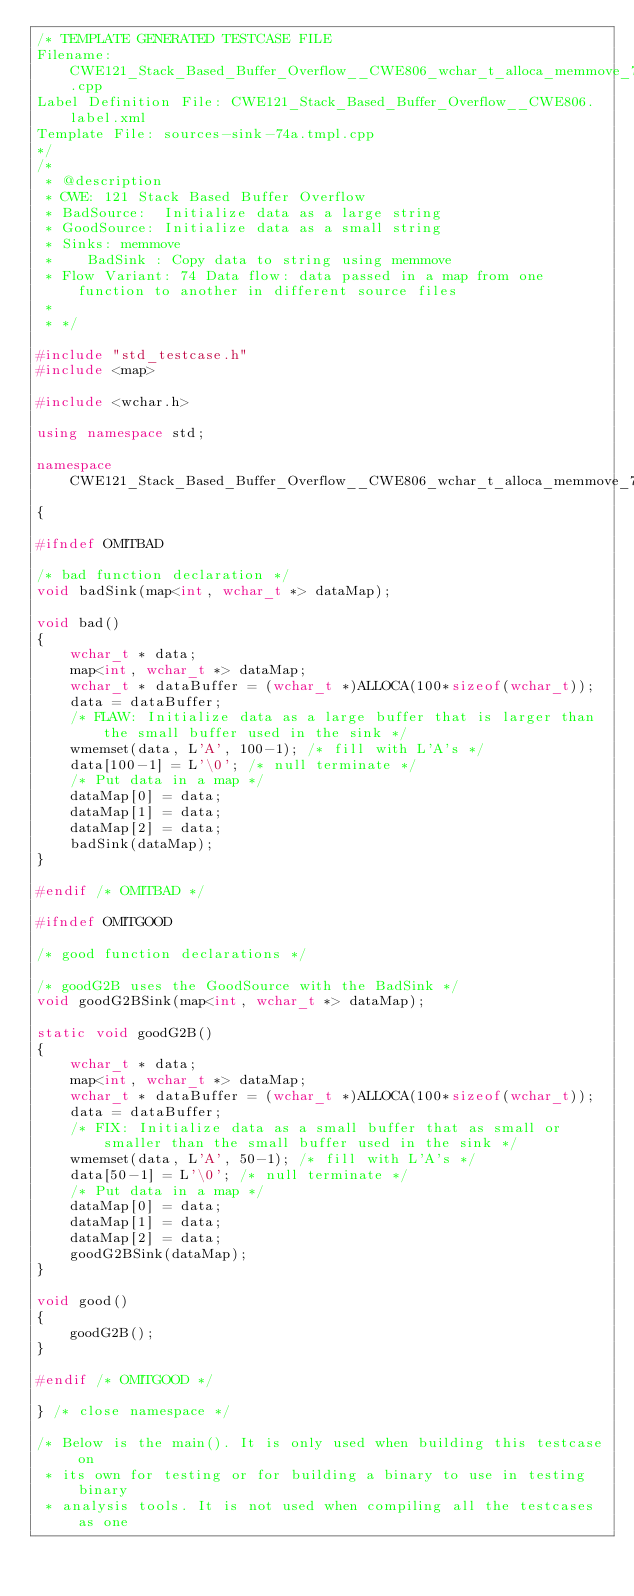<code> <loc_0><loc_0><loc_500><loc_500><_C++_>/* TEMPLATE GENERATED TESTCASE FILE
Filename: CWE121_Stack_Based_Buffer_Overflow__CWE806_wchar_t_alloca_memmove_74a.cpp
Label Definition File: CWE121_Stack_Based_Buffer_Overflow__CWE806.label.xml
Template File: sources-sink-74a.tmpl.cpp
*/
/*
 * @description
 * CWE: 121 Stack Based Buffer Overflow
 * BadSource:  Initialize data as a large string
 * GoodSource: Initialize data as a small string
 * Sinks: memmove
 *    BadSink : Copy data to string using memmove
 * Flow Variant: 74 Data flow: data passed in a map from one function to another in different source files
 *
 * */

#include "std_testcase.h"
#include <map>

#include <wchar.h>

using namespace std;

namespace CWE121_Stack_Based_Buffer_Overflow__CWE806_wchar_t_alloca_memmove_74
{

#ifndef OMITBAD

/* bad function declaration */
void badSink(map<int, wchar_t *> dataMap);

void bad()
{
    wchar_t * data;
    map<int, wchar_t *> dataMap;
    wchar_t * dataBuffer = (wchar_t *)ALLOCA(100*sizeof(wchar_t));
    data = dataBuffer;
    /* FLAW: Initialize data as a large buffer that is larger than the small buffer used in the sink */
    wmemset(data, L'A', 100-1); /* fill with L'A's */
    data[100-1] = L'\0'; /* null terminate */
    /* Put data in a map */
    dataMap[0] = data;
    dataMap[1] = data;
    dataMap[2] = data;
    badSink(dataMap);
}

#endif /* OMITBAD */

#ifndef OMITGOOD

/* good function declarations */

/* goodG2B uses the GoodSource with the BadSink */
void goodG2BSink(map<int, wchar_t *> dataMap);

static void goodG2B()
{
    wchar_t * data;
    map<int, wchar_t *> dataMap;
    wchar_t * dataBuffer = (wchar_t *)ALLOCA(100*sizeof(wchar_t));
    data = dataBuffer;
    /* FIX: Initialize data as a small buffer that as small or smaller than the small buffer used in the sink */
    wmemset(data, L'A', 50-1); /* fill with L'A's */
    data[50-1] = L'\0'; /* null terminate */
    /* Put data in a map */
    dataMap[0] = data;
    dataMap[1] = data;
    dataMap[2] = data;
    goodG2BSink(dataMap);
}

void good()
{
    goodG2B();
}

#endif /* OMITGOOD */

} /* close namespace */

/* Below is the main(). It is only used when building this testcase on
 * its own for testing or for building a binary to use in testing binary
 * analysis tools. It is not used when compiling all the testcases as one</code> 